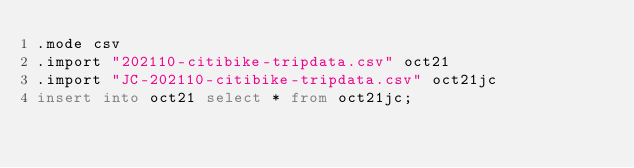<code> <loc_0><loc_0><loc_500><loc_500><_SQL_>.mode csv
.import "202110-citibike-tripdata.csv" oct21
.import "JC-202110-citibike-tripdata.csv" oct21jc
insert into oct21 select * from oct21jc;
</code> 